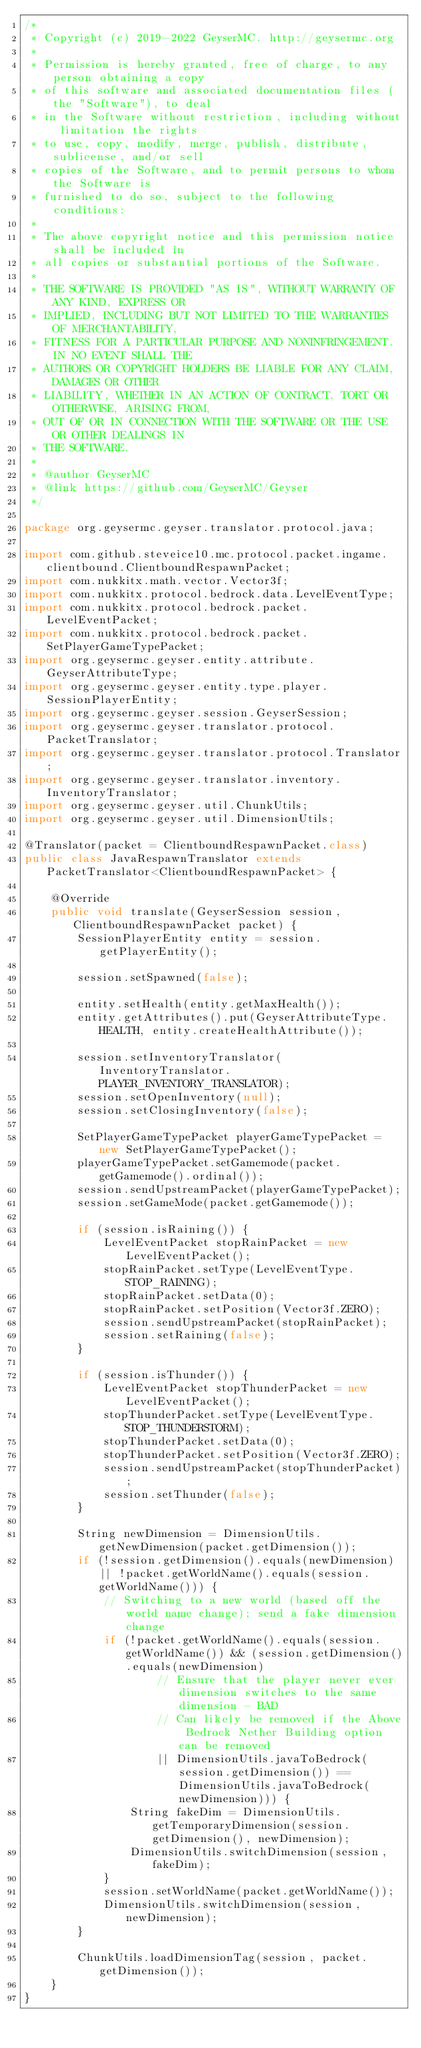<code> <loc_0><loc_0><loc_500><loc_500><_Java_>/*
 * Copyright (c) 2019-2022 GeyserMC. http://geysermc.org
 *
 * Permission is hereby granted, free of charge, to any person obtaining a copy
 * of this software and associated documentation files (the "Software"), to deal
 * in the Software without restriction, including without limitation the rights
 * to use, copy, modify, merge, publish, distribute, sublicense, and/or sell
 * copies of the Software, and to permit persons to whom the Software is
 * furnished to do so, subject to the following conditions:
 *
 * The above copyright notice and this permission notice shall be included in
 * all copies or substantial portions of the Software.
 *
 * THE SOFTWARE IS PROVIDED "AS IS", WITHOUT WARRANTY OF ANY KIND, EXPRESS OR
 * IMPLIED, INCLUDING BUT NOT LIMITED TO THE WARRANTIES OF MERCHANTABILITY,
 * FITNESS FOR A PARTICULAR PURPOSE AND NONINFRINGEMENT. IN NO EVENT SHALL THE
 * AUTHORS OR COPYRIGHT HOLDERS BE LIABLE FOR ANY CLAIM, DAMAGES OR OTHER
 * LIABILITY, WHETHER IN AN ACTION OF CONTRACT, TORT OR OTHERWISE, ARISING FROM,
 * OUT OF OR IN CONNECTION WITH THE SOFTWARE OR THE USE OR OTHER DEALINGS IN
 * THE SOFTWARE.
 *
 * @author GeyserMC
 * @link https://github.com/GeyserMC/Geyser
 */

package org.geysermc.geyser.translator.protocol.java;

import com.github.steveice10.mc.protocol.packet.ingame.clientbound.ClientboundRespawnPacket;
import com.nukkitx.math.vector.Vector3f;
import com.nukkitx.protocol.bedrock.data.LevelEventType;
import com.nukkitx.protocol.bedrock.packet.LevelEventPacket;
import com.nukkitx.protocol.bedrock.packet.SetPlayerGameTypePacket;
import org.geysermc.geyser.entity.attribute.GeyserAttributeType;
import org.geysermc.geyser.entity.type.player.SessionPlayerEntity;
import org.geysermc.geyser.session.GeyserSession;
import org.geysermc.geyser.translator.protocol.PacketTranslator;
import org.geysermc.geyser.translator.protocol.Translator;
import org.geysermc.geyser.translator.inventory.InventoryTranslator;
import org.geysermc.geyser.util.ChunkUtils;
import org.geysermc.geyser.util.DimensionUtils;

@Translator(packet = ClientboundRespawnPacket.class)
public class JavaRespawnTranslator extends PacketTranslator<ClientboundRespawnPacket> {

    @Override
    public void translate(GeyserSession session, ClientboundRespawnPacket packet) {
        SessionPlayerEntity entity = session.getPlayerEntity();

        session.setSpawned(false);

        entity.setHealth(entity.getMaxHealth());
        entity.getAttributes().put(GeyserAttributeType.HEALTH, entity.createHealthAttribute());

        session.setInventoryTranslator(InventoryTranslator.PLAYER_INVENTORY_TRANSLATOR);
        session.setOpenInventory(null);
        session.setClosingInventory(false);

        SetPlayerGameTypePacket playerGameTypePacket = new SetPlayerGameTypePacket();
        playerGameTypePacket.setGamemode(packet.getGamemode().ordinal());
        session.sendUpstreamPacket(playerGameTypePacket);
        session.setGameMode(packet.getGamemode());

        if (session.isRaining()) {
            LevelEventPacket stopRainPacket = new LevelEventPacket();
            stopRainPacket.setType(LevelEventType.STOP_RAINING);
            stopRainPacket.setData(0);
            stopRainPacket.setPosition(Vector3f.ZERO);
            session.sendUpstreamPacket(stopRainPacket);
            session.setRaining(false);
        }

        if (session.isThunder()) {
            LevelEventPacket stopThunderPacket = new LevelEventPacket();
            stopThunderPacket.setType(LevelEventType.STOP_THUNDERSTORM);
            stopThunderPacket.setData(0);
            stopThunderPacket.setPosition(Vector3f.ZERO);
            session.sendUpstreamPacket(stopThunderPacket);
            session.setThunder(false);
        }

        String newDimension = DimensionUtils.getNewDimension(packet.getDimension());
        if (!session.getDimension().equals(newDimension) || !packet.getWorldName().equals(session.getWorldName())) {
            // Switching to a new world (based off the world name change); send a fake dimension change
            if (!packet.getWorldName().equals(session.getWorldName()) && (session.getDimension().equals(newDimension)
                    // Ensure that the player never ever dimension switches to the same dimension - BAD
                    // Can likely be removed if the Above Bedrock Nether Building option can be removed
                    || DimensionUtils.javaToBedrock(session.getDimension()) == DimensionUtils.javaToBedrock(newDimension))) {
                String fakeDim = DimensionUtils.getTemporaryDimension(session.getDimension(), newDimension);
                DimensionUtils.switchDimension(session, fakeDim);
            }
            session.setWorldName(packet.getWorldName());
            DimensionUtils.switchDimension(session, newDimension);
        }

        ChunkUtils.loadDimensionTag(session, packet.getDimension());
    }
}
</code> 